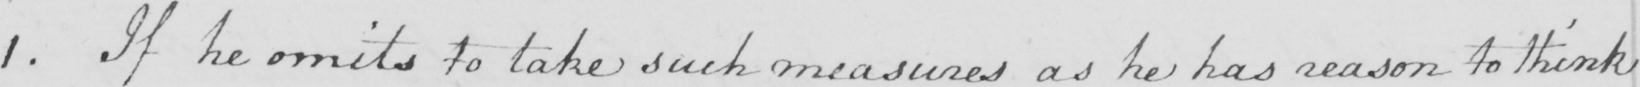Can you tell me what this handwritten text says? 1 . If he omits to take such measures as he has reason to think 